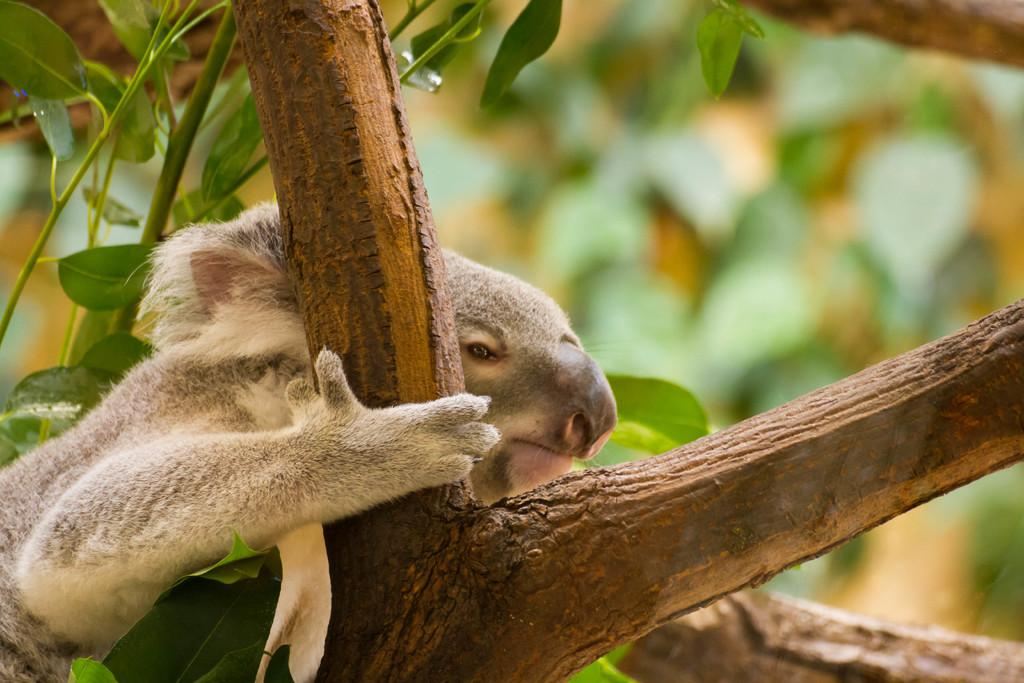What type of animal can be seen in the image? There is an animal in the image, but its specific type cannot be determined from the provided facts. Where is the animal located in the image? The animal is on the branches of a tree. What can be seen in the background of the image? There are leaves visible in the background of the image. What type of plant is the men using to water the garden in the image? There are no men or gardens present in the image, and therefore no such activity can be observed. 